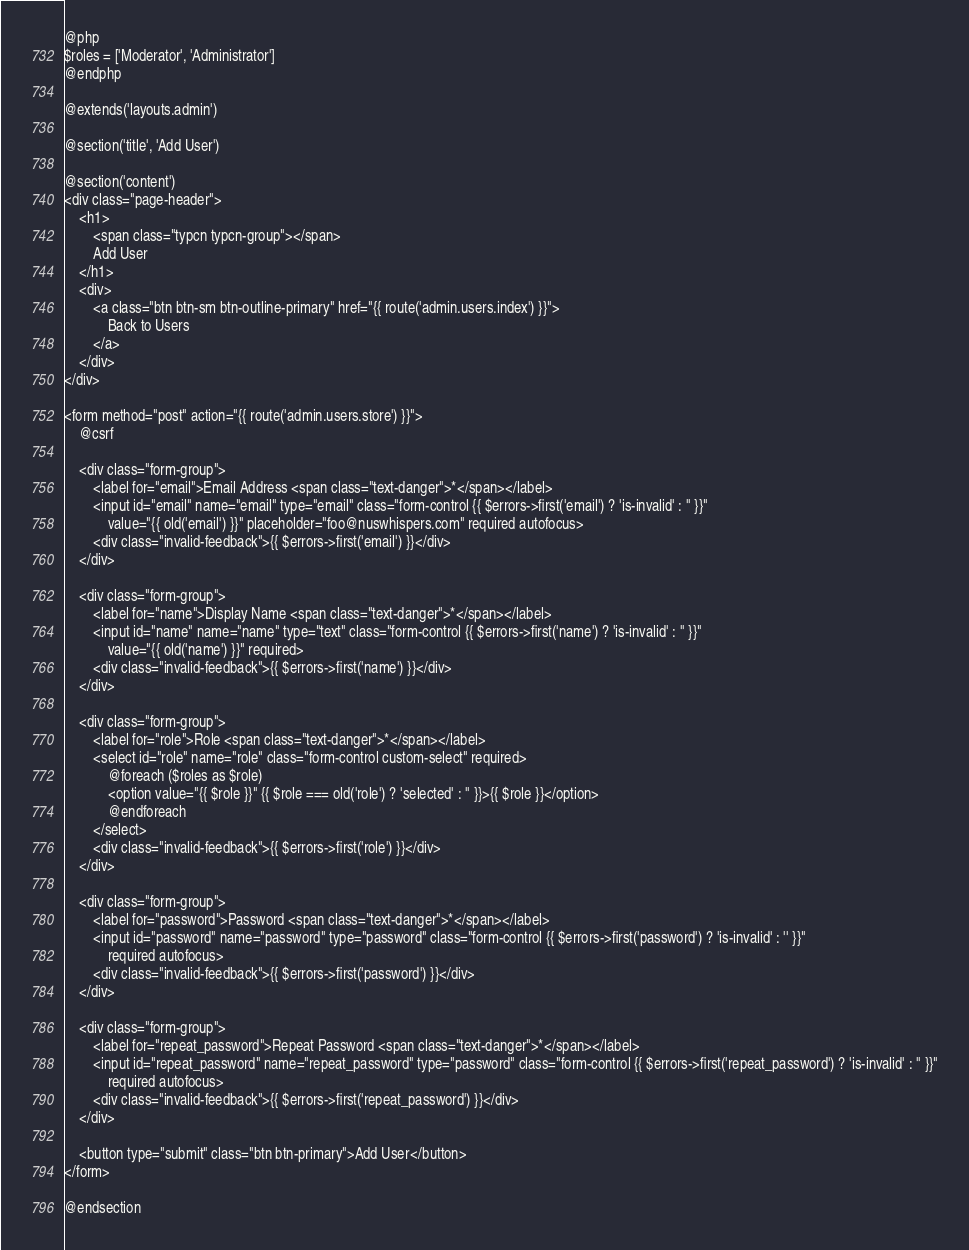<code> <loc_0><loc_0><loc_500><loc_500><_PHP_>@php
$roles = ['Moderator', 'Administrator']
@endphp

@extends('layouts.admin')

@section('title', 'Add User')

@section('content')
<div class="page-header">
    <h1>
        <span class="typcn typcn-group"></span>
        Add User
    </h1>
    <div>
        <a class="btn btn-sm btn-outline-primary" href="{{ route('admin.users.index') }}">
            Back to Users
        </a>
    </div>
</div>

<form method="post" action="{{ route('admin.users.store') }}">
    @csrf

    <div class="form-group">
        <label for="email">Email Address <span class="text-danger">*</span></label>
        <input id="email" name="email" type="email" class="form-control {{ $errors->first('email') ? 'is-invalid' : '' }}"
            value="{{ old('email') }}" placeholder="foo@nuswhispers.com" required autofocus>
        <div class="invalid-feedback">{{ $errors->first('email') }}</div>
    </div>

    <div class="form-group">
        <label for="name">Display Name <span class="text-danger">*</span></label>
        <input id="name" name="name" type="text" class="form-control {{ $errors->first('name') ? 'is-invalid' : '' }}"
            value="{{ old('name') }}" required>
        <div class="invalid-feedback">{{ $errors->first('name') }}</div>
    </div>

    <div class="form-group">
        <label for="role">Role <span class="text-danger">*</span></label>
        <select id="role" name="role" class="form-control custom-select" required>
            @foreach ($roles as $role)
            <option value="{{ $role }}" {{ $role === old('role') ? 'selected' : '' }}>{{ $role }}</option>
            @endforeach
        </select>
        <div class="invalid-feedback">{{ $errors->first('role') }}</div>
    </div>

    <div class="form-group">
        <label for="password">Password <span class="text-danger">*</span></label>
        <input id="password" name="password" type="password" class="form-control {{ $errors->first('password') ? 'is-invalid' : '' }}"
            required autofocus>
        <div class="invalid-feedback">{{ $errors->first('password') }}</div>
    </div>

    <div class="form-group">
        <label for="repeat_password">Repeat Password <span class="text-danger">*</span></label>
        <input id="repeat_password" name="repeat_password" type="password" class="form-control {{ $errors->first('repeat_password') ? 'is-invalid' : '' }}"
            required autofocus>
        <div class="invalid-feedback">{{ $errors->first('repeat_password') }}</div>
    </div>

    <button type="submit" class="btn btn-primary">Add User</button>
</form>

@endsection
</code> 